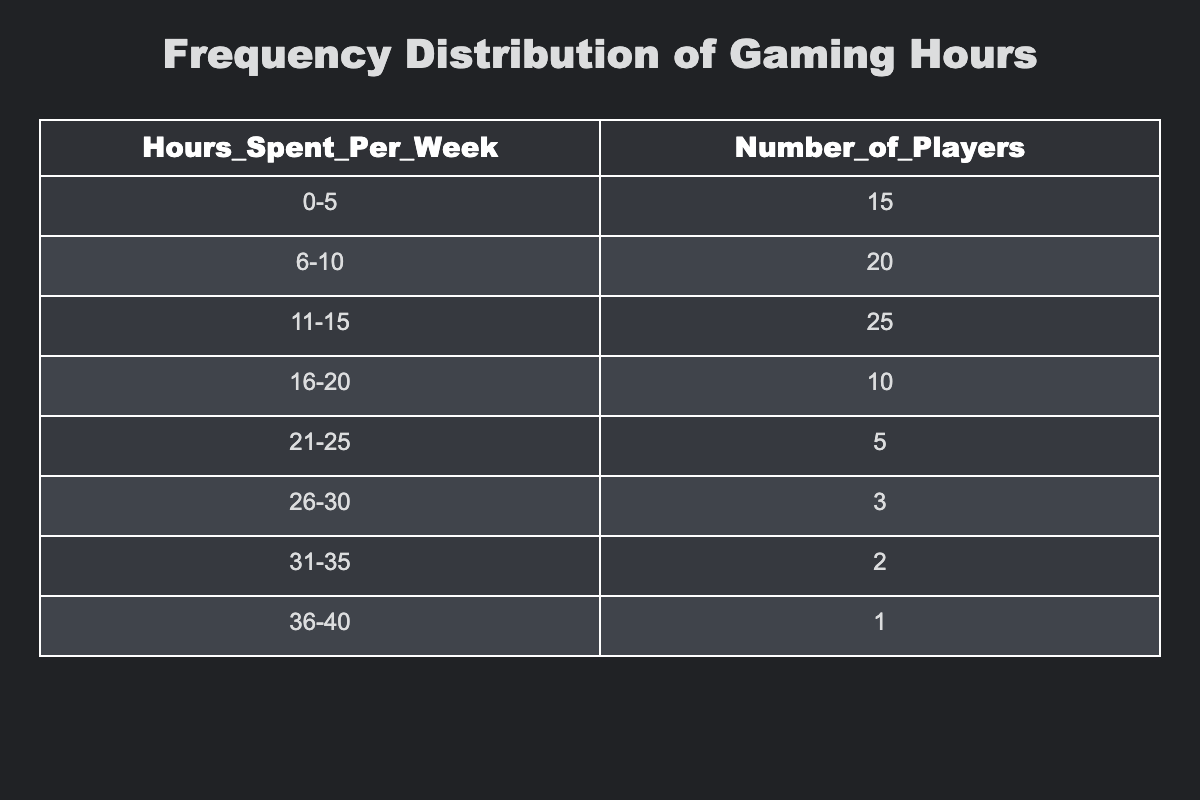What is the number of players who spent 0-5 hours gaming per week? The table shows that 15 players fall into the 0-5 hours category. This information is directly available in the first row of the table.
Answer: 15 How many players were surveyed in total? To find the total number of players, we add the numbers from all categories: 15 + 20 + 25 + 10 + 5 + 3 + 2 + 1 = 81. So, there were 81 players surveyed.
Answer: 81 What is the range of hours spent gaming by the most players? The 11-15 hours category has the highest number of players at 25. This means the range with the most players is 11-15 hours.
Answer: 11-15 How many players dedicated more than 20 hours to gaming? Players who dedicated more than 20 hours are in the categories 21-25, 26-30, 31-35, and 36-40. Adding those, we get 5 + 3 + 2 + 1 = 11 players.
Answer: 11 Is it true that more players spent between 6-10 hours than those who spent 21-25 hours? The table shows 20 players in the 6-10 hours category and 5 players in the 21-25 hours category. Since 20 is greater than 5, the statement is true.
Answer: Yes What is the average number of hours spent gaming by the surveyed players? To find the average, we will first calculate the total hours spent per category and then divide that by the total number of players. The weighted contributions are: (2.5*15) + (8*20) + (13*25) + (18*10) + (23*5) + (28*3) + (33*2) + (38*1) = 513. Thus, the average is 513/81 = 6.33.
Answer: 6.33 How many more players spent between 16-20 hours compared to those who spent 26-30 hours? According to the table, there are 10 players in the 16-20 hours category and 3 players in the 26-30 hours category. The difference is 10 - 3 = 7 players.
Answer: 7 What is the total number of players who spent 15 hours or less gaming? This includes the categories 0-5, 6-10, 11-15. Adding these gives us 15 + 20 + 25 = 60 players.
Answer: 60 Were there any players who spent more than 35 hours gaming? The table does not list any players in the category greater than 35 hours (the highest listed is 36-40 with only 1 player). Therefore, there are no players above 35 hours gaming.
Answer: No 